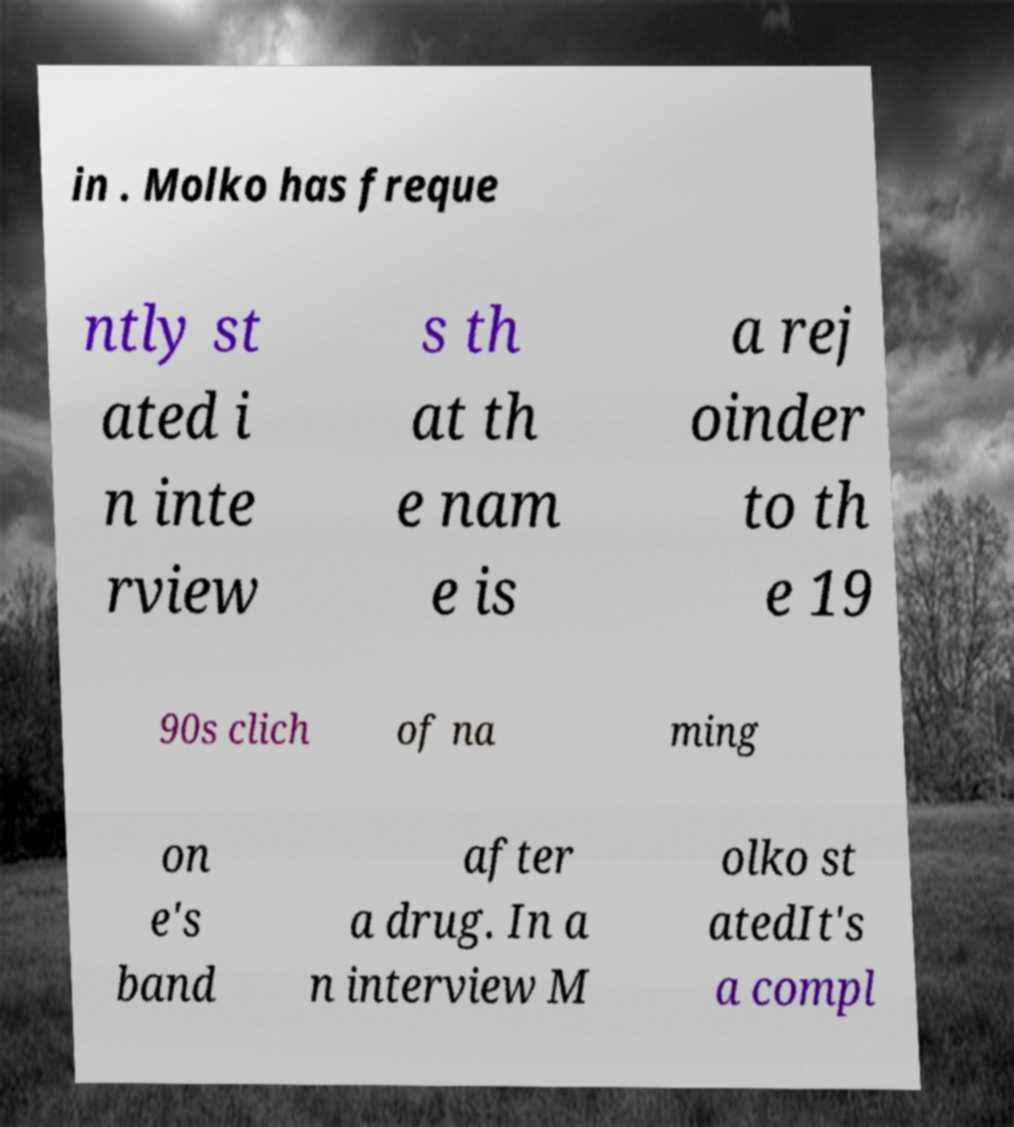For documentation purposes, I need the text within this image transcribed. Could you provide that? in . Molko has freque ntly st ated i n inte rview s th at th e nam e is a rej oinder to th e 19 90s clich of na ming on e's band after a drug. In a n interview M olko st atedIt's a compl 